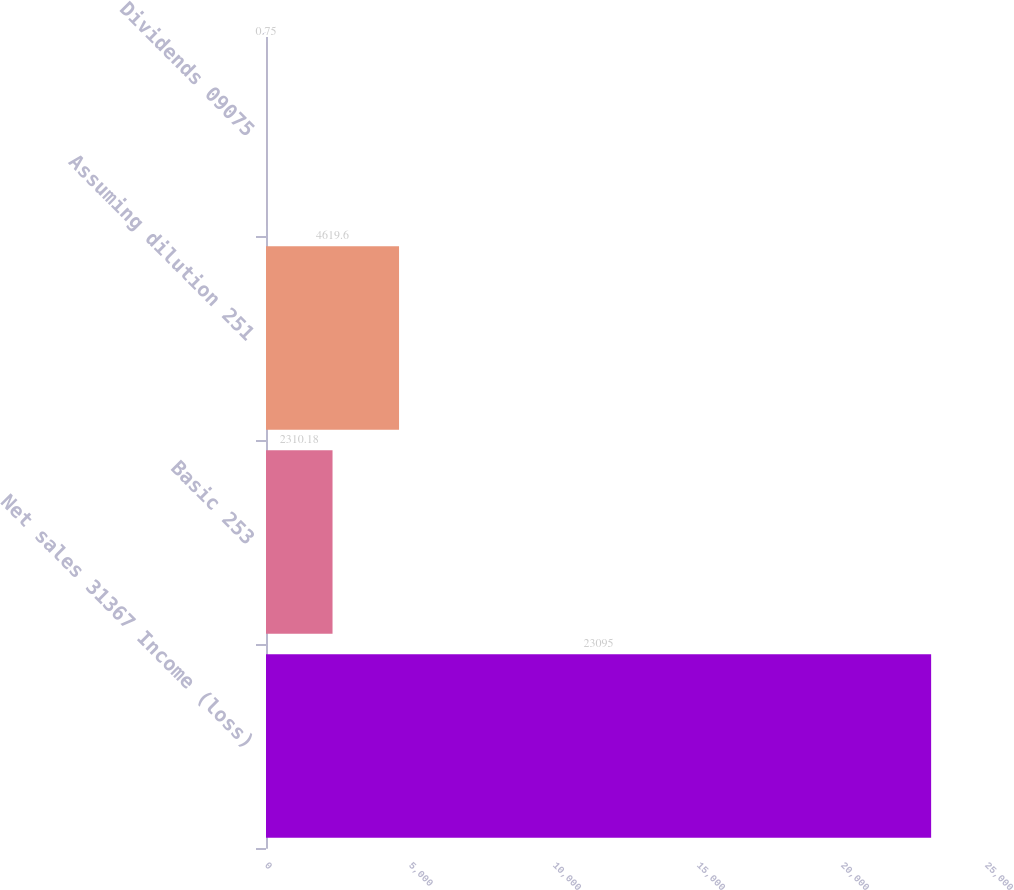Convert chart. <chart><loc_0><loc_0><loc_500><loc_500><bar_chart><fcel>Net sales 31367 Income (loss)<fcel>Basic 253<fcel>Assuming dilution 251<fcel>Dividends 09075<nl><fcel>23095<fcel>2310.18<fcel>4619.6<fcel>0.75<nl></chart> 